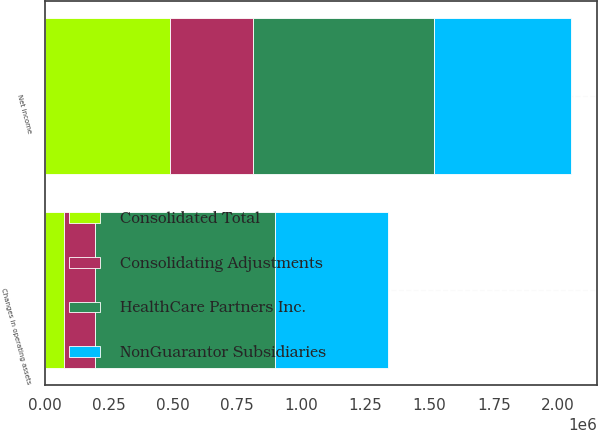Convert chart. <chart><loc_0><loc_0><loc_500><loc_500><stacked_bar_chart><ecel><fcel>Net income<fcel>Changes in operating assets<nl><fcel>NonGuarantor Subsidiaries<fcel>536017<fcel>439200<nl><fcel>Consolidated Total<fcel>487077<fcel>75180<nl><fcel>Consolidating Adjustments<fcel>323195<fcel>118579<nl><fcel>HealthCare Partners Inc.<fcel>705052<fcel>705052<nl></chart> 